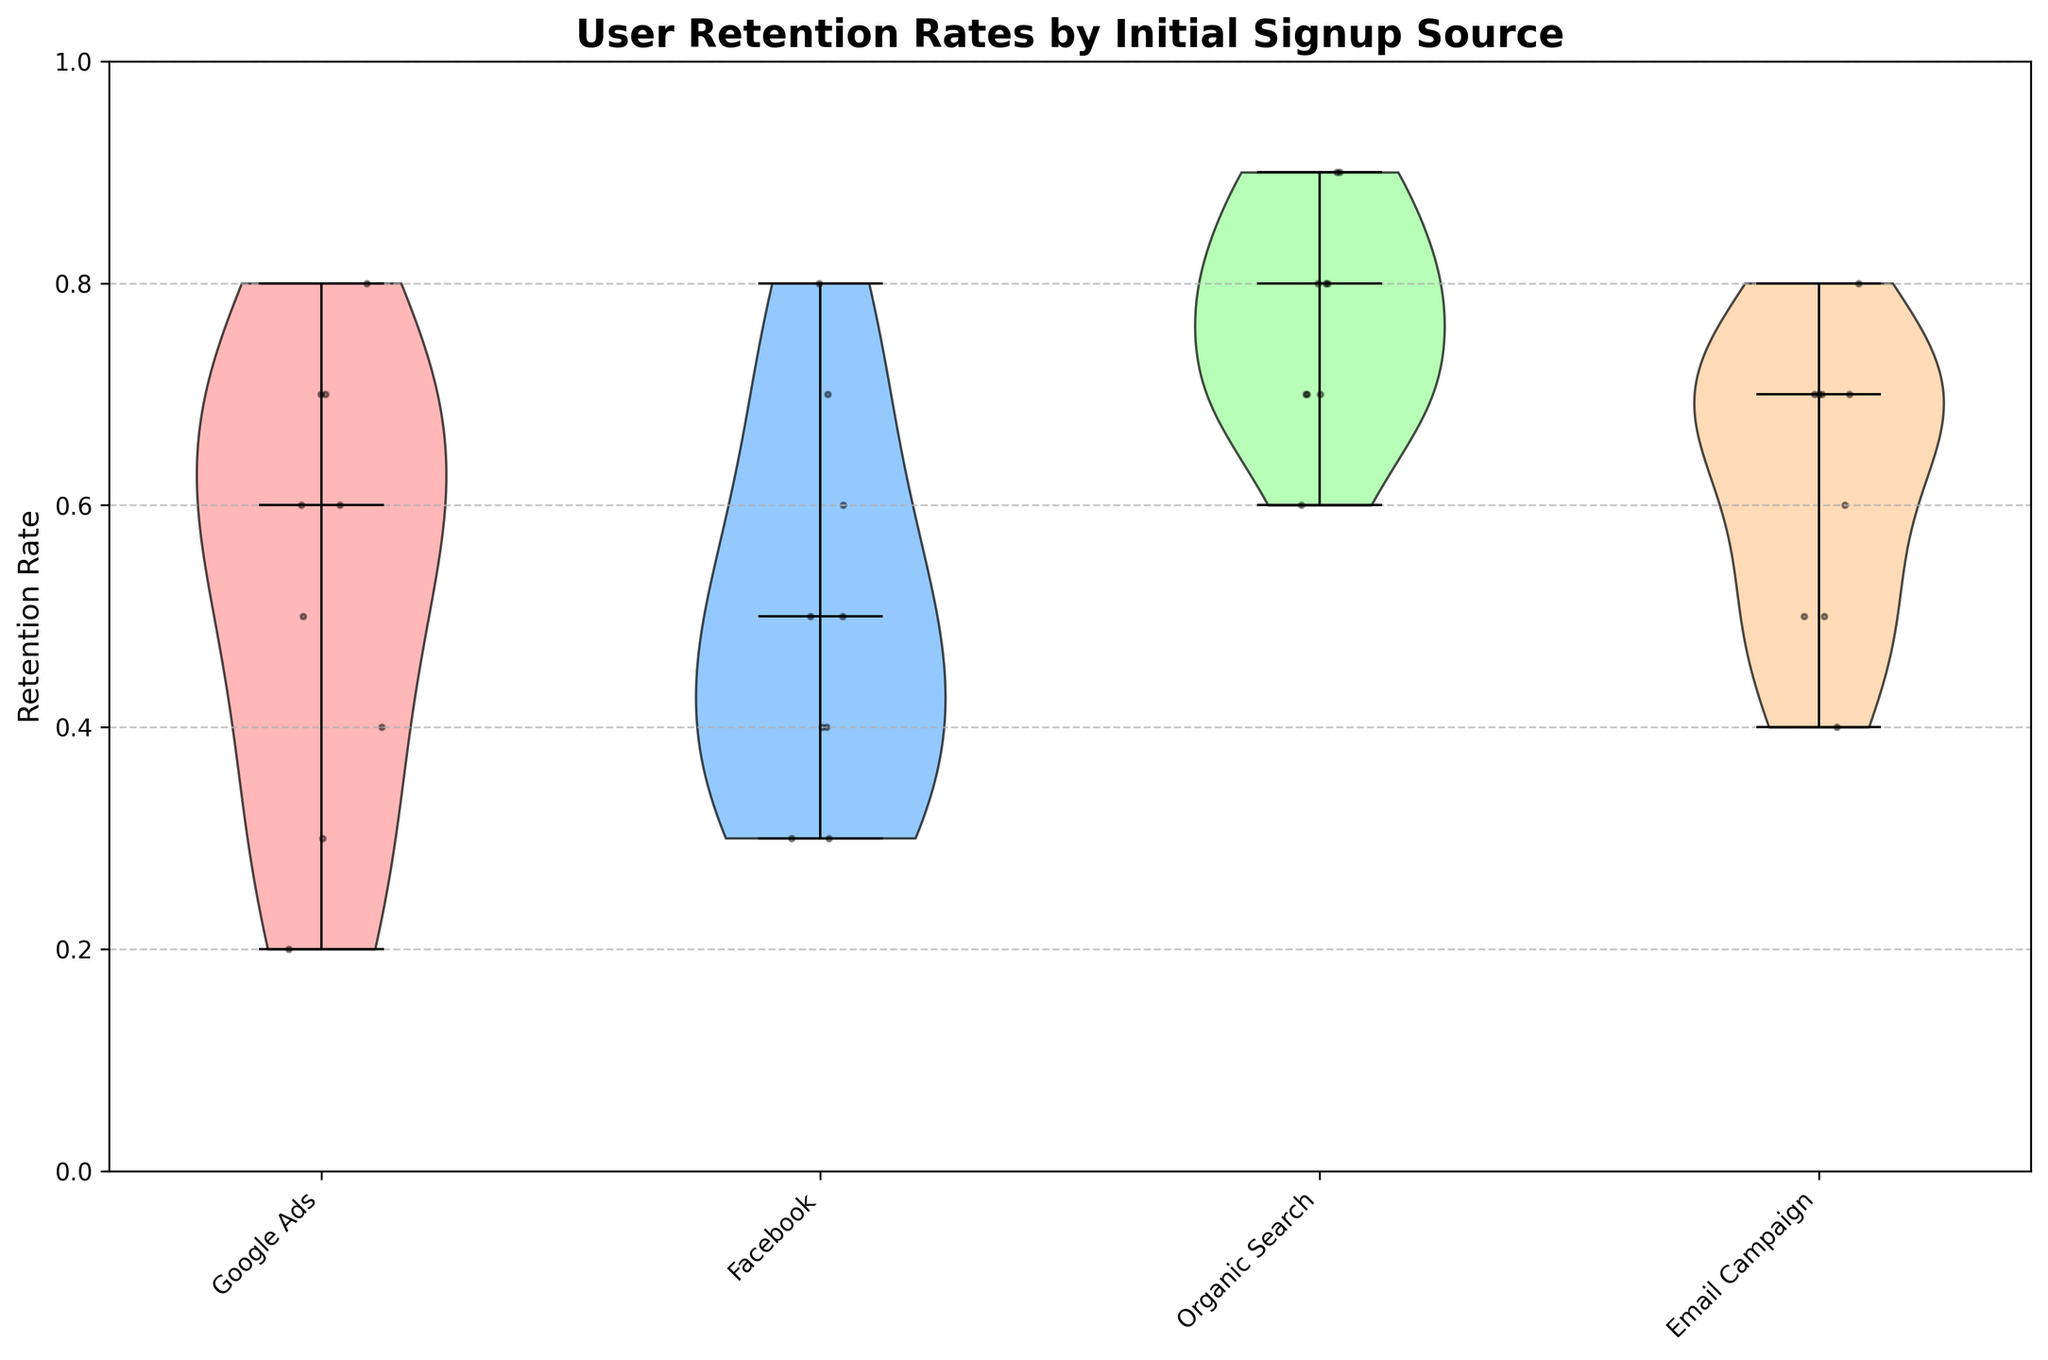What is the title of the figure? The title of the plot is located at the top center and it summarizes what the figure is about.
Answer: User Retention Rates by Initial Signup Source How many signup sources are shown in the figure? Count the number of different categories on the x-axis, which represent the signup sources.
Answer: 4 What color is used for the Google Ads violin plot? Look for the color of the violin that represents the Google Ads data points.
Answer: Light red Which signup source has the highest spread of user retention rates? Compare the spread (width) of the violin plots representing each signup source.
Answer: Organic Search What is the median retention rate for users from Facebook? Locate the black horizontal line within the Facebook violin plot.
Answer: 0.5 How do the retention rates vary within each signup source? Analyze the shape and spread of each violin plot. Narrow plots indicate less variance, while wider plots indicate more variance.
Answer: Google Ads: Widely varies; Facebook: Moderate variance; Organic Search: Consistent with low variance; Email Campaign: Consistent with low variance Which signup source appears to have the most stable retention rate over time? Look for the narrowest and most concentrated violin plot, indicating less variance.
Answer: Organic Search Compare the median retention rates between Google Ads and Email Campaign. Compare the positions of the black horizontal lines (medians) in the Google Ads and Email Campaign violin plots.
Answer: Google Ads < Email Campaign What is the relationship between the retention rates of users who signed up from Organic Search compared to those from Facebook? Compare the spread, median, and overall shape of the violin plots for both signup sources.
Answer: Organic Search has higher and more stable retention rates How does the distribution of retention rates differ between Facebook and Organic Search? Compare the overall shape and spread of the violin plots for Facebook and Organic Search. Facebook has a wider spread and lower median, whereas Organic Search is narrower with a higher and more consistent median.
Answer: Facebook has more variation and lower overall retention rates compared to Organic Search 